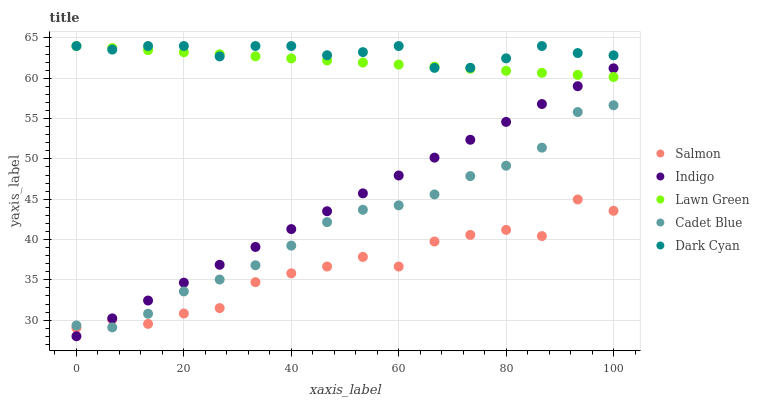Does Salmon have the minimum area under the curve?
Answer yes or no. Yes. Does Dark Cyan have the maximum area under the curve?
Answer yes or no. Yes. Does Indigo have the minimum area under the curve?
Answer yes or no. No. Does Indigo have the maximum area under the curve?
Answer yes or no. No. Is Lawn Green the smoothest?
Answer yes or no. Yes. Is Salmon the roughest?
Answer yes or no. Yes. Is Indigo the smoothest?
Answer yes or no. No. Is Indigo the roughest?
Answer yes or no. No. Does Indigo have the lowest value?
Answer yes or no. Yes. Does Cadet Blue have the lowest value?
Answer yes or no. No. Does Lawn Green have the highest value?
Answer yes or no. Yes. Does Indigo have the highest value?
Answer yes or no. No. Is Indigo less than Dark Cyan?
Answer yes or no. Yes. Is Dark Cyan greater than Cadet Blue?
Answer yes or no. Yes. Does Salmon intersect Indigo?
Answer yes or no. Yes. Is Salmon less than Indigo?
Answer yes or no. No. Is Salmon greater than Indigo?
Answer yes or no. No. Does Indigo intersect Dark Cyan?
Answer yes or no. No. 